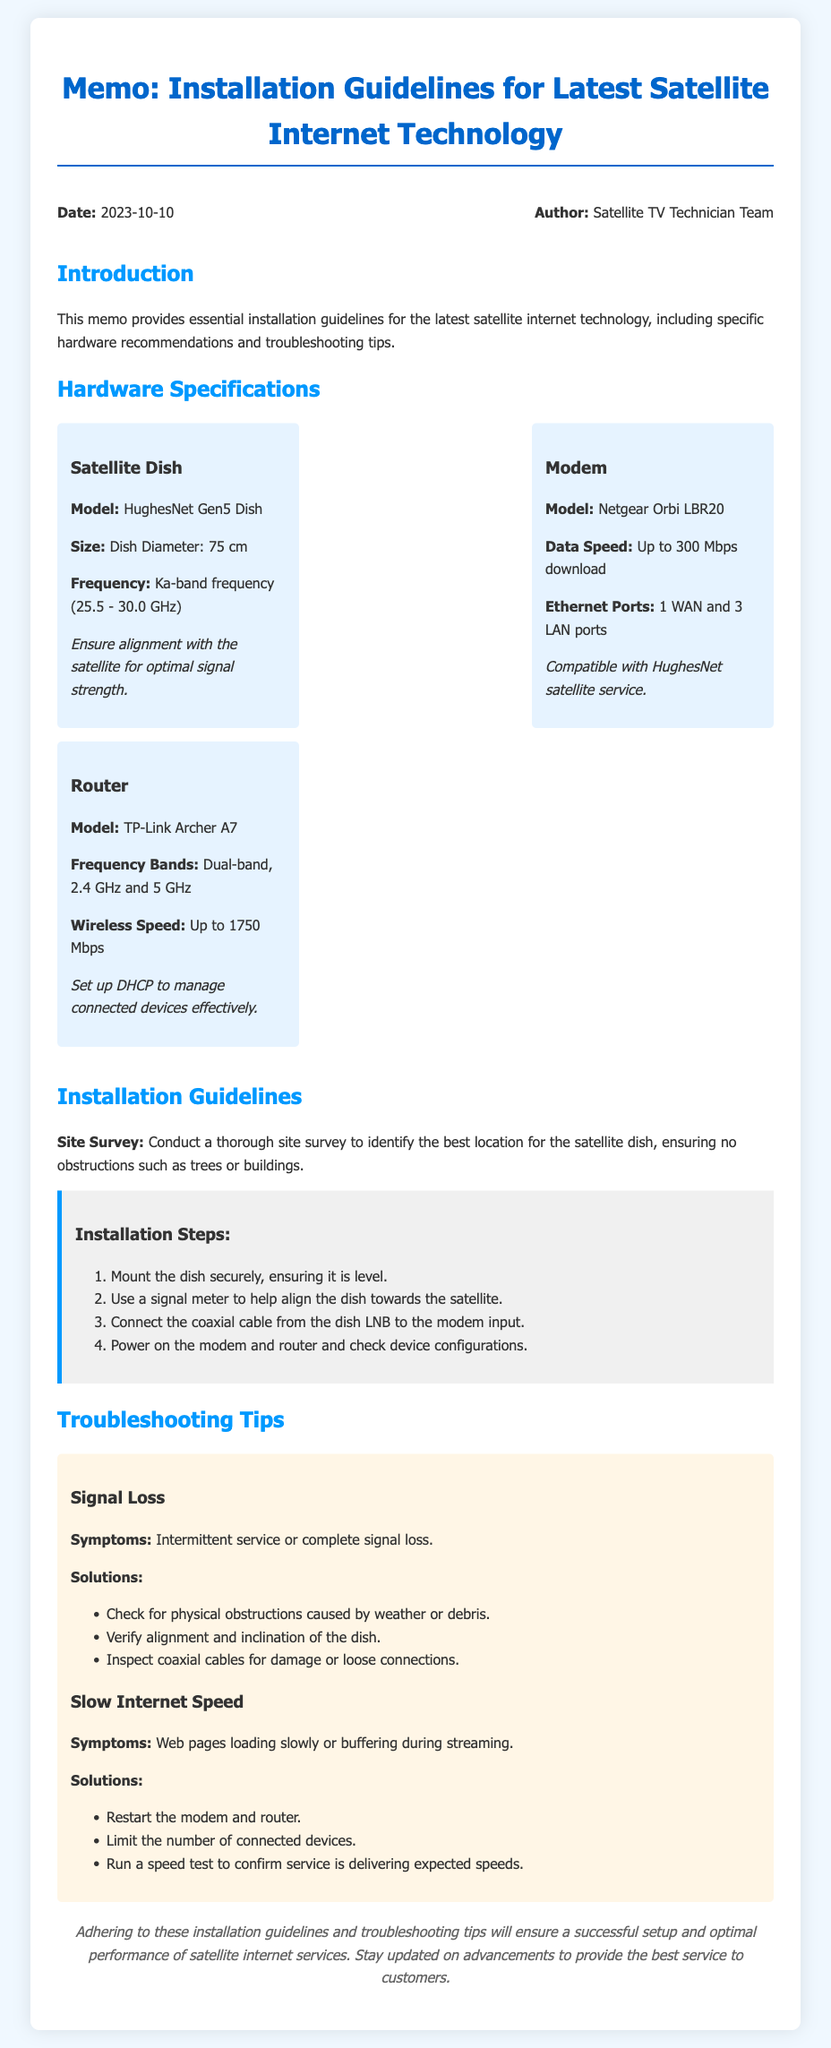What is the model of the satellite dish? The model of the satellite dish is specified in the hardware specifications section of the document.
Answer: HughesNet Gen5 Dish What is the diameter of the dish? The diameter of the dish is mentioned alongside the model specifications.
Answer: 75 cm What is the maximum download speed of the modem? The maximum download speed is provided in the modem hardware specifications.
Answer: Up to 300 Mbps How many Ethernet ports does the modem have? The number of Ethernet ports is stated in the modem's hardware specifications.
Answer: 1 WAN and 3 LAN ports What frequency bands does the router support? The supported frequency bands are indicated in the router's specifications.
Answer: Dual-band, 2.4 GHz and 5 GHz What is the first step in the installation guidelines? The first step is outlined in the installation steps section of the document.
Answer: Mount the dish securely, ensuring it is level What should you check for signal loss? The symptoms and solutions for signal loss are listed in the troubleshooting tips.
Answer: Verify alignment and inclination of the dish How can slow internet speed symptoms be identified? Symptoms of slow internet speed are listed in the troubleshooting tips section.
Answer: Web pages loading slowly or buffering during streaming What kind of memo is this document? The type of document is made clear in the introduction of the memo.
Answer: Installation Guidelines for Latest Satellite Internet Technology 